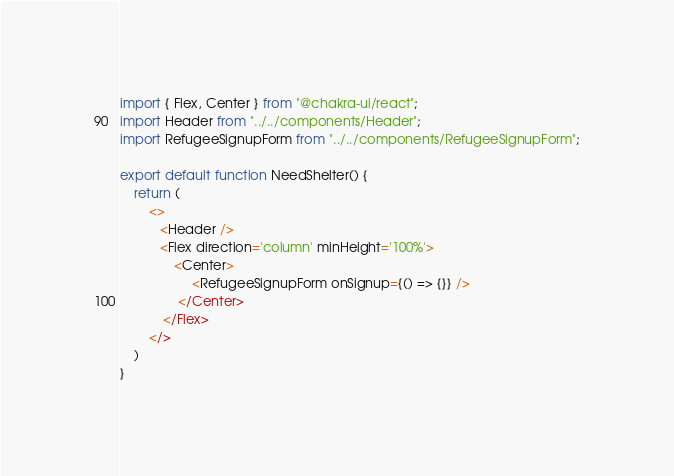<code> <loc_0><loc_0><loc_500><loc_500><_TypeScript_>import { Flex, Center } from "@chakra-ui/react";
import Header from "../../components/Header";
import RefugeeSignupForm from "../../components/RefugeeSignupForm";

export default function NeedShelter() {
    return (
        <>
           <Header />
           <Flex direction='column' minHeight='100%'>
               <Center>
                    <RefugeeSignupForm onSignup={() => {}} />
                </Center>
            </Flex>
        </>
    )
}</code> 